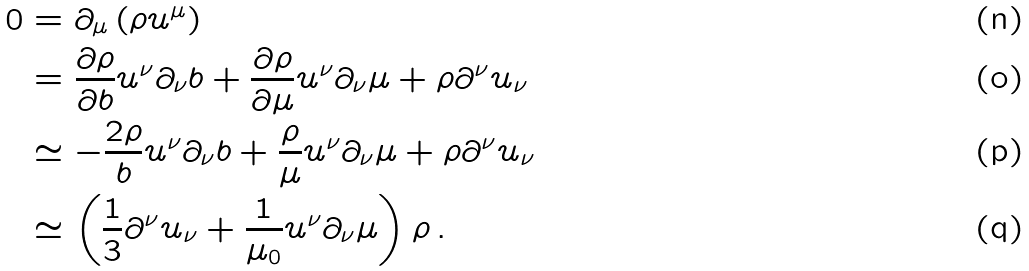<formula> <loc_0><loc_0><loc_500><loc_500>0 & = \partial _ { \mu } \left ( \rho u ^ { \mu } \right ) \\ & = \frac { \partial \rho } { \partial b } u ^ { \nu } \partial _ { \nu } b + \frac { \partial \rho } { \partial \mu } u ^ { \nu } \partial _ { \nu } \mu + \rho \partial ^ { \nu } u _ { \nu } \\ & \simeq - \frac { 2 \rho } { b } u ^ { \nu } \partial _ { \nu } b + \frac { \rho } { \mu } u ^ { \nu } \partial _ { \nu } \mu + \rho \partial ^ { \nu } u _ { \nu } \\ & \simeq \left ( \frac { 1 } { 3 } \partial ^ { \nu } u _ { \nu } + \frac { 1 } { \mu _ { 0 } } u ^ { \nu } \partial _ { \nu } \mu \right ) \rho \, .</formula> 